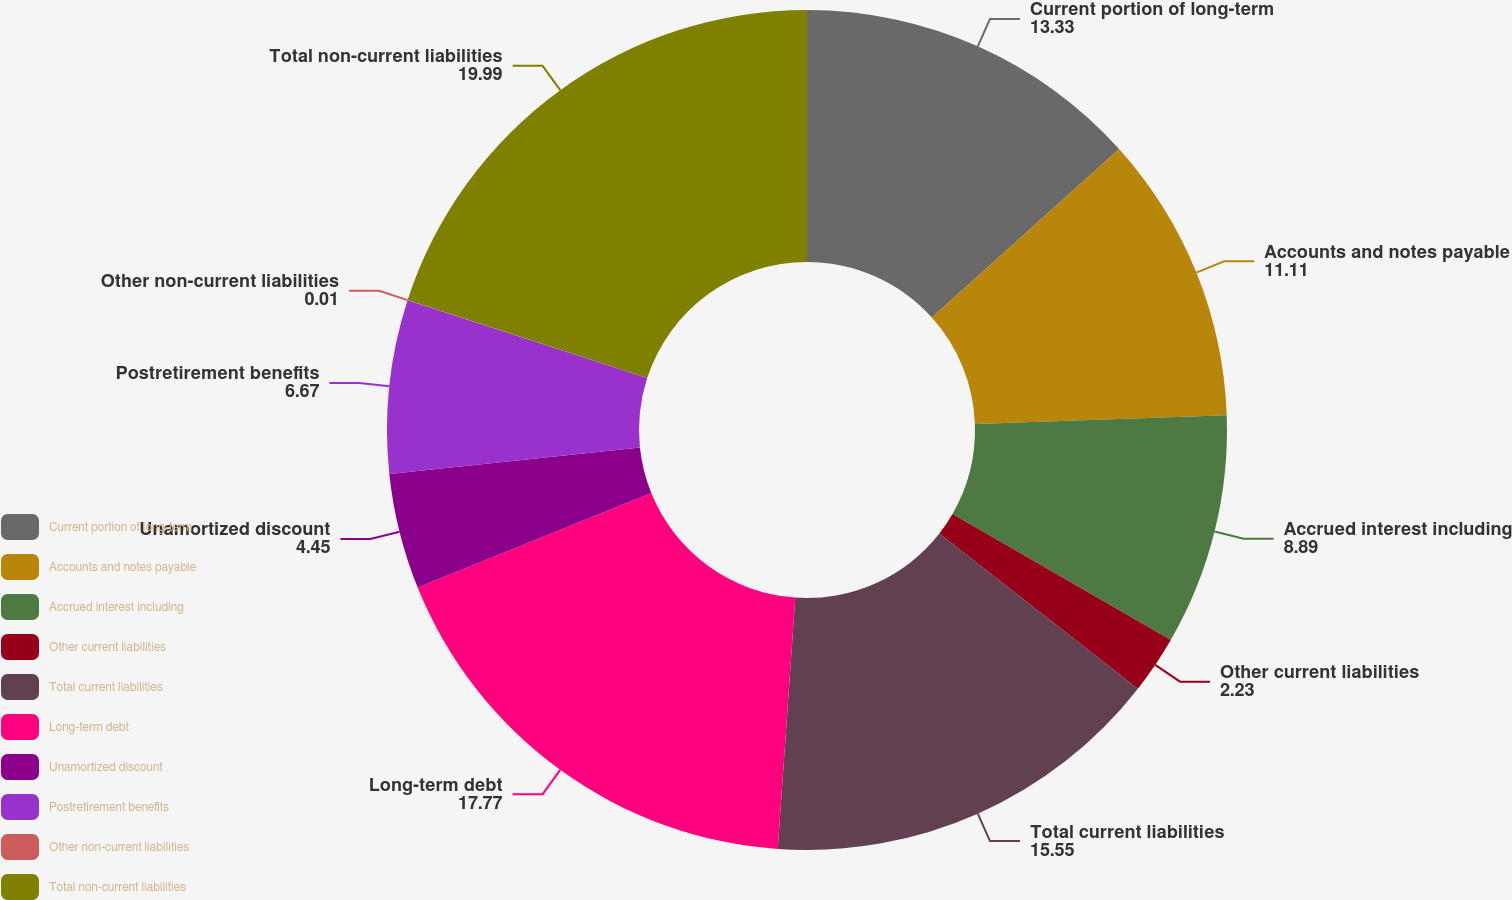Convert chart to OTSL. <chart><loc_0><loc_0><loc_500><loc_500><pie_chart><fcel>Current portion of long-term<fcel>Accounts and notes payable<fcel>Accrued interest including<fcel>Other current liabilities<fcel>Total current liabilities<fcel>Long-term debt<fcel>Unamortized discount<fcel>Postretirement benefits<fcel>Other non-current liabilities<fcel>Total non-current liabilities<nl><fcel>13.33%<fcel>11.11%<fcel>8.89%<fcel>2.23%<fcel>15.55%<fcel>17.77%<fcel>4.45%<fcel>6.67%<fcel>0.01%<fcel>19.99%<nl></chart> 